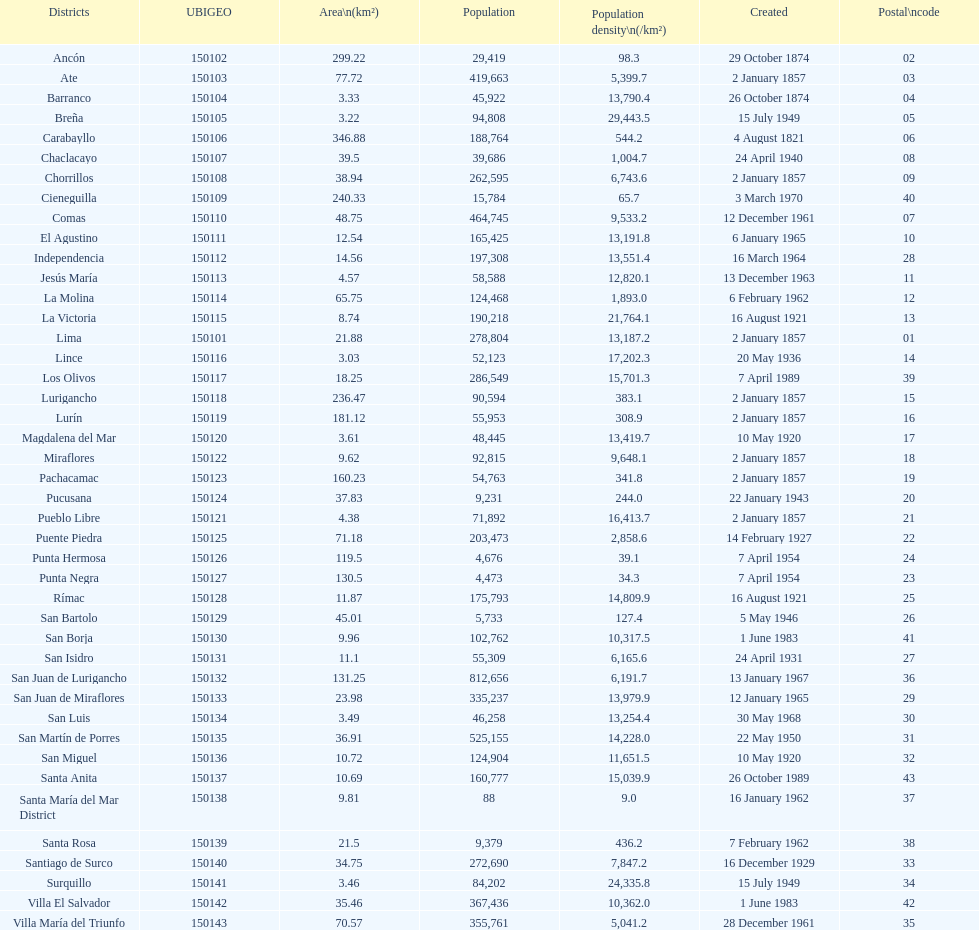How many districts have more than 100,000 people in this city? 21. 